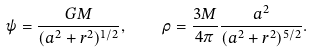<formula> <loc_0><loc_0><loc_500><loc_500>\psi = \frac { G M } { ( a ^ { 2 } + r ^ { 2 } ) ^ { 1 / 2 } } , \quad \rho = \frac { 3 M } { 4 \pi } \frac { a ^ { 2 } } { ( a ^ { 2 } + r ^ { 2 } ) ^ { 5 / 2 } } .</formula> 